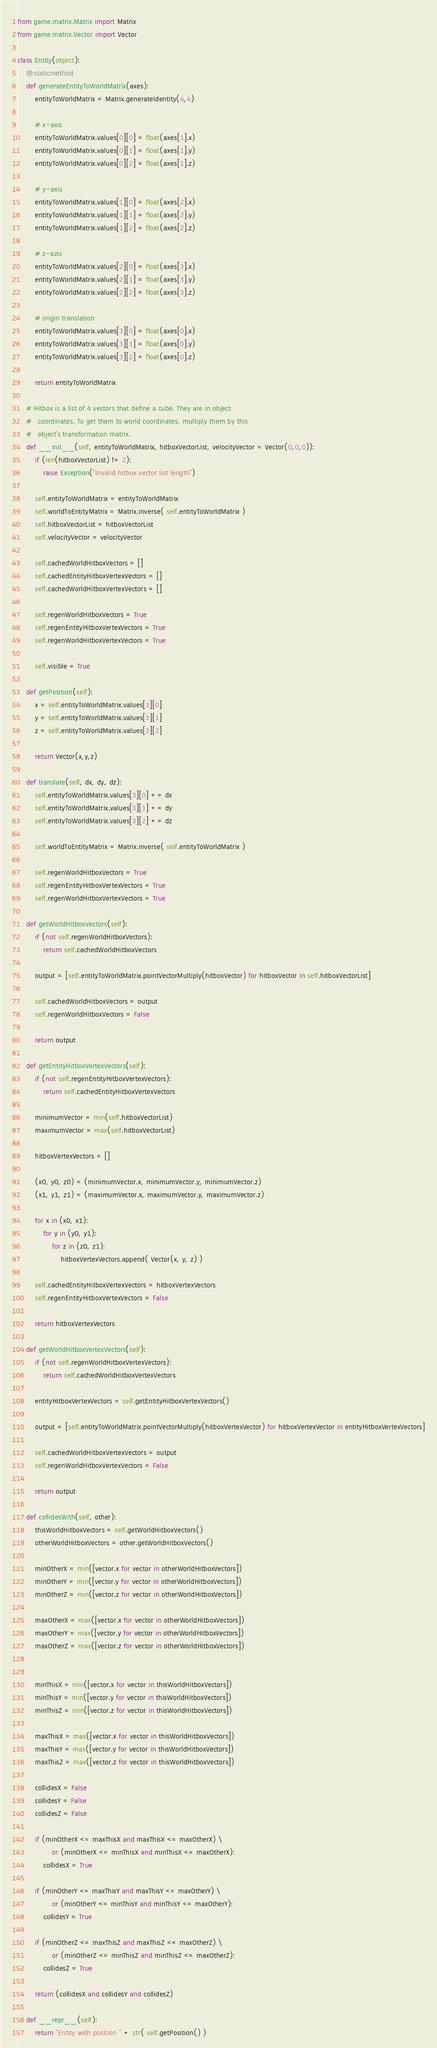Convert code to text. <code><loc_0><loc_0><loc_500><loc_500><_Python_>from game.matrix.Matrix import Matrix
from game.matrix.Vector import Vector

class Entity(object):
    @staticmethod
    def generateEntityToWorldMatrix(axes):
        entityToWorldMatrix = Matrix.generateIdentity(4,4)

        # x-axis
        entityToWorldMatrix.values[0][0] = float(axes[1].x)
        entityToWorldMatrix.values[0][1] = float(axes[1].y)
        entityToWorldMatrix.values[0][2] = float(axes[1].z)

        # y-axis
        entityToWorldMatrix.values[1][0] = float(axes[2].x)
        entityToWorldMatrix.values[1][1] = float(axes[2].y)
        entityToWorldMatrix.values[1][2] = float(axes[2].z)

        # z-azis
        entityToWorldMatrix.values[2][0] = float(axes[3].x)
        entityToWorldMatrix.values[2][1] = float(axes[3].y)
        entityToWorldMatrix.values[2][2] = float(axes[3].z)

        # origin translation
        entityToWorldMatrix.values[3][0] = float(axes[0].x)
        entityToWorldMatrix.values[3][1] = float(axes[0].y)
        entityToWorldMatrix.values[3][2] = float(axes[0].z)

        return entityToWorldMatrix

    # Hitbox is a list of 4 vectors that define a cube. They are in object
    #   coordinates. To get them to world coordinates, multiply them by this
    #   object's transformation matrix.
    def __init__(self, entityToWorldMatrix, hitboxVectorList, velocityVector = Vector(0,0,0)):
        if (len(hitboxVectorList) != 2):
            raise Exception("Invalid hitbox vector list length")

        self.entityToWorldMatrix = entityToWorldMatrix
        self.worldToEntityMatrix = Matrix.inverse( self.entityToWorldMatrix )
        self.hitboxVectorList = hitboxVectorList
        self.velocityVector = velocityVector

        self.cachedWorldHitboxVectors = []
        self.cachedEntityHitboxVertexVectors = []
        self.cachedWorldHitboxVertexVectors = []

        self.regenWorldHitboxVectors = True
        self.regenEntityHitboxVertexVectors = True
        self.regenWorldHitboxVertexVectors = True

        self.visible = True

    def getPosition(self):
        x = self.entityToWorldMatrix.values[3][0]
        y = self.entityToWorldMatrix.values[3][1]
        z = self.entityToWorldMatrix.values[3][2]

        return Vector(x,y,z)

    def translate(self, dx, dy, dz):
        self.entityToWorldMatrix.values[3][0] += dx
        self.entityToWorldMatrix.values[3][1] += dy
        self.entityToWorldMatrix.values[3][2] += dz

        self.worldToEntityMatrix = Matrix.inverse( self.entityToWorldMatrix )

        self.regenWorldHitboxVectors = True
        self.regenEntityHitboxVertexVectors = True
        self.regenWorldHitboxVertexVectors = True
    
    def getWorldHitboxVectors(self):
        if (not self.regenWorldHitboxVectors):
            return self.cachedWorldHitboxVectors

        output = [self.entityToWorldMatrix.pointVectorMultiply(hitboxVector) for hitboxVector in self.hitboxVectorList]

        self.cachedWorldHitboxVectors = output
        self.regenWorldHitboxVectors = False

        return output

    def getEntityHitboxVertexVectors(self):
        if (not self.regenEntityHitboxVertexVectors):
            return self.cachedEntityHitboxVertexVectors

        minimumVector = min(self.hitboxVectorList)
        maximumVector = max(self.hitboxVectorList)

        hitboxVertexVectors = []

        (x0, y0, z0) = (minimumVector.x, minimumVector.y, minimumVector.z)
        (x1, y1, z1) = (maximumVector.x, maximumVector.y, maximumVector.z)

        for x in (x0, x1):
            for y in (y0, y1):
                for z in (z0, z1):
                    hitboxVertexVectors.append( Vector(x, y, z) )

        self.cachedEntityHitboxVertexVectors = hitboxVertexVectors
        self.regenEntityHitboxVertexVectors = False

        return hitboxVertexVectors

    def getWorldHitboxVertexVectors(self):
        if (not self.regenWorldHitboxVertexVectors):
            return self.cachedWorldHitboxVertexVectors

        entityHitboxVertexVectors = self.getEntityHitboxVertexVectors()

        output = [self.entityToWorldMatrix.pointVectorMultiply(hitboxVertexVector) for hitboxVertexVector in entityHitboxVertexVectors]

        self.cachedWorldHitboxVertexVectors = output
        self.regenWorldHitboxVertexVectors = False

        return output

    def collidesWith(self, other):
        thisWorldHitboxVectors = self.getWorldHitboxVectors()
        otherWorldHitboxVectors = other.getWorldHitboxVectors()

        minOtherX = min([vector.x for vector in otherWorldHitboxVectors])
        minOtherY = min([vector.y for vector in otherWorldHitboxVectors])
        minOtherZ = min([vector.z for vector in otherWorldHitboxVectors])
        
        maxOtherX = max([vector.x for vector in otherWorldHitboxVectors])
        maxOtherY = max([vector.y for vector in otherWorldHitboxVectors])
        maxOtherZ = max([vector.z for vector in otherWorldHitboxVectors])


        minThisX = min([vector.x for vector in thisWorldHitboxVectors])
        minThisY = min([vector.y for vector in thisWorldHitboxVectors])
        minThisZ = min([vector.z for vector in thisWorldHitboxVectors])

        maxThisX = max([vector.x for vector in thisWorldHitboxVectors])
        maxThisY = max([vector.y for vector in thisWorldHitboxVectors])
        maxThisZ = max([vector.z for vector in thisWorldHitboxVectors])

        collidesX = False
        collidesY = False
        collidesZ = False

        if (minOtherX <= maxThisX and maxThisX <= maxOtherX) \
                or (minOtherX <= minThisX and minThisX <= maxOtherX):
            collidesX = True

        if (minOtherY <= maxThisY and maxThisY <= maxOtherY) \
                or (minOtherY <= minThisY and minThisY <= maxOtherY):
            collidesY = True

        if (minOtherZ <= maxThisZ and maxThisZ <= maxOtherZ) \
                or (minOtherZ <= minThisZ and minThisZ <= maxOtherZ):
            collidesZ = True

        return (collidesX and collidesY and collidesZ)

    def __repr__(self):
        return "Entity with position " + str( self.getPosition() )</code> 